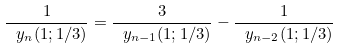<formula> <loc_0><loc_0><loc_500><loc_500>\frac { 1 } { \ y _ { n } ( 1 ; 1 / 3 ) } = \frac { 3 } { \ y _ { n - 1 } ( 1 ; 1 / 3 ) } - \frac { 1 } { \ y _ { n - 2 } ( 1 ; 1 / 3 ) }</formula> 